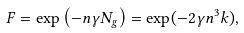Convert formula to latex. <formula><loc_0><loc_0><loc_500><loc_500>F = \exp \left ( - n \gamma N _ { g } \right ) = \exp ( - 2 \gamma n ^ { 3 } k ) ,</formula> 